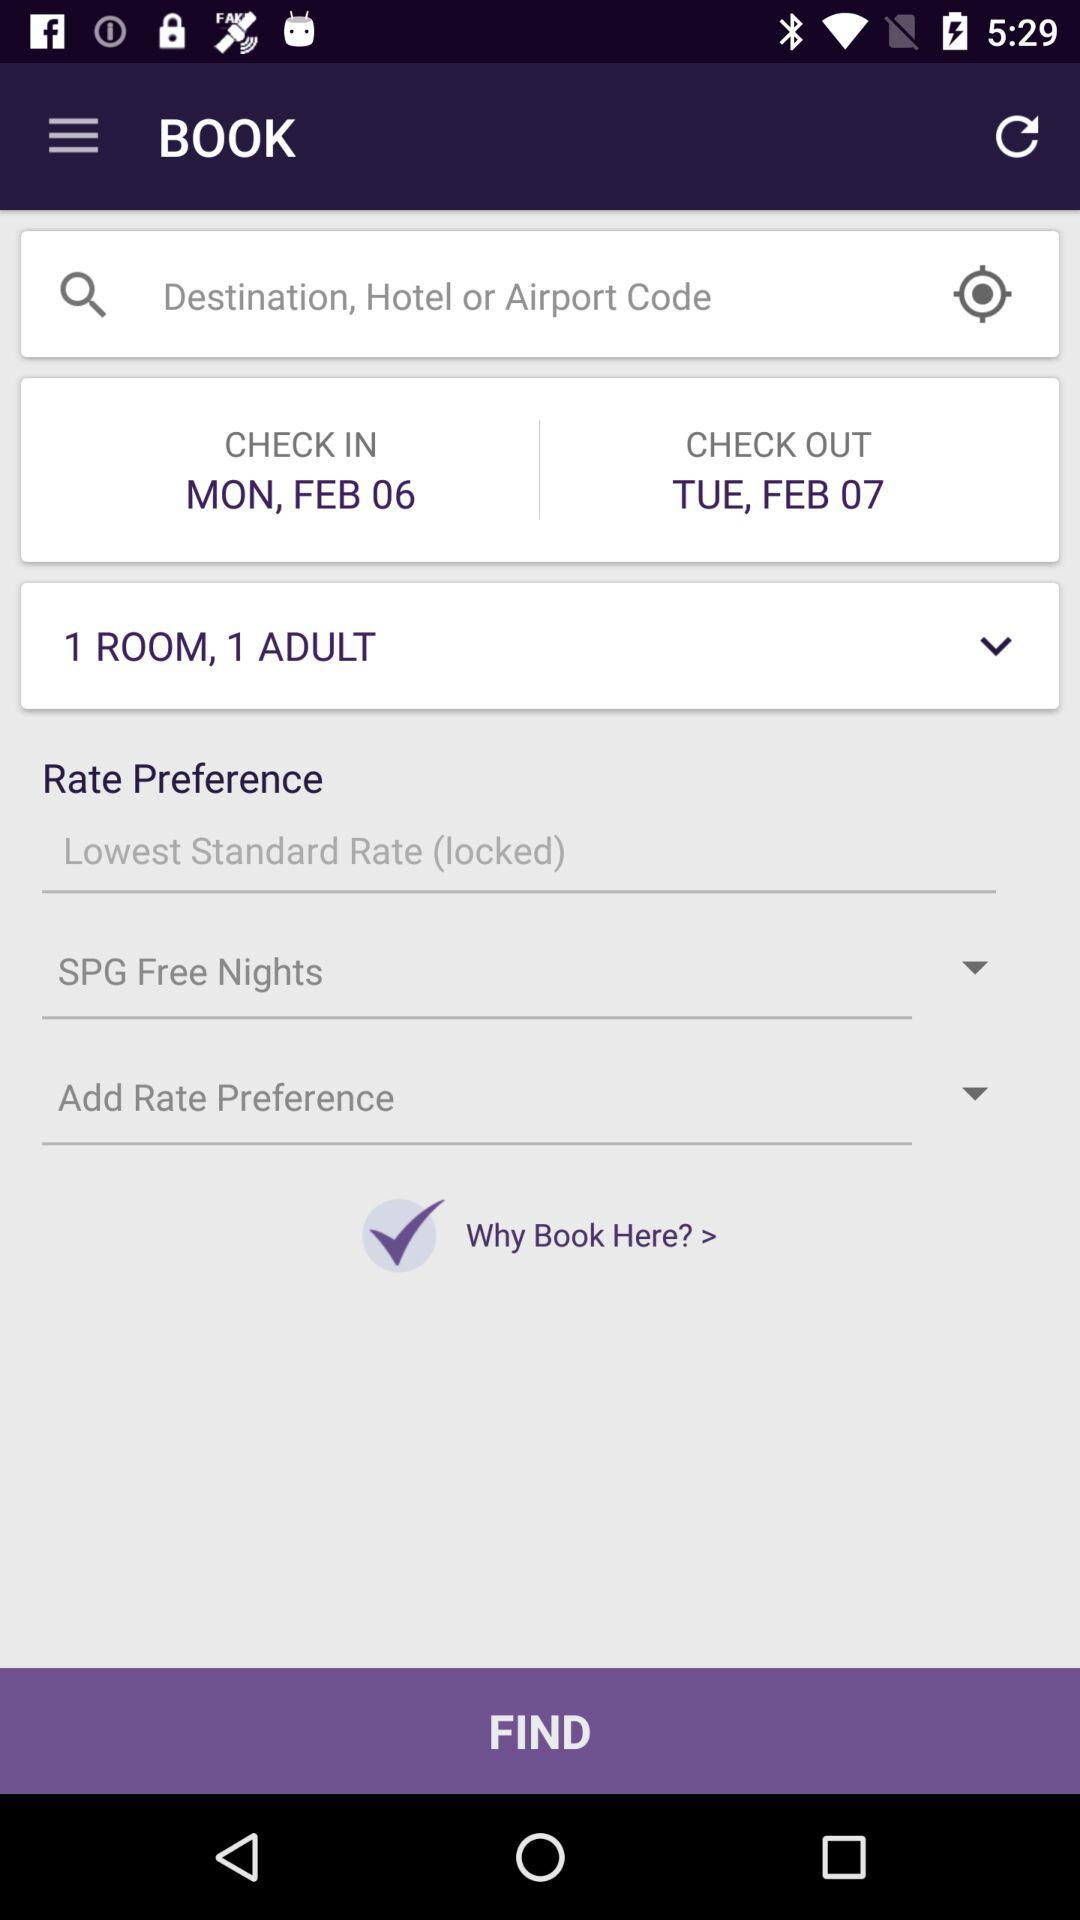What is the check-in date? The check-in date is Monday, February 6. 